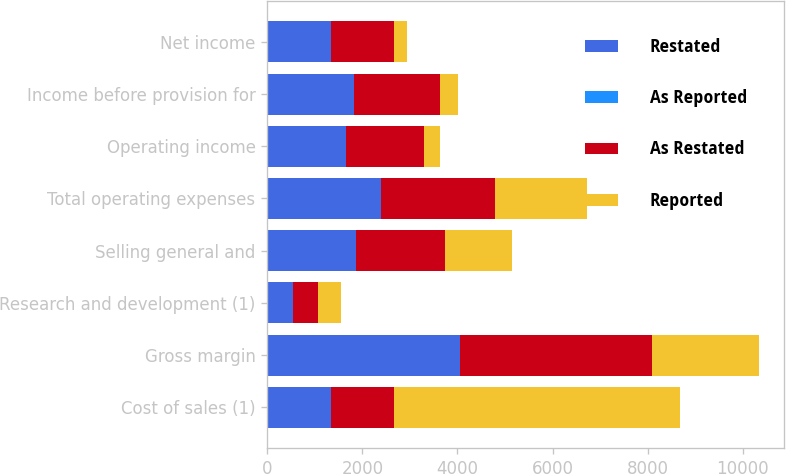Convert chart. <chart><loc_0><loc_0><loc_500><loc_500><stacked_bar_chart><ecel><fcel>Cost of sales (1)<fcel>Gross margin<fcel>Research and development (1)<fcel>Selling general and<fcel>Total operating expenses<fcel>Operating income<fcel>Income before provision for<fcel>Net income<nl><fcel>Restated<fcel>1331.5<fcel>4043<fcel>534<fcel>1859<fcel>2393<fcel>1650<fcel>1815<fcel>1335<nl><fcel>As Reported<fcel>1<fcel>1<fcel>1<fcel>5<fcel>6<fcel>7<fcel>7<fcel>7<nl><fcel>As Restated<fcel>1331.5<fcel>4042<fcel>535<fcel>1864<fcel>2399<fcel>1643<fcel>1808<fcel>1328<nl><fcel>Reported<fcel>6020<fcel>2259<fcel>489<fcel>1421<fcel>1933<fcel>326<fcel>383<fcel>276<nl></chart> 